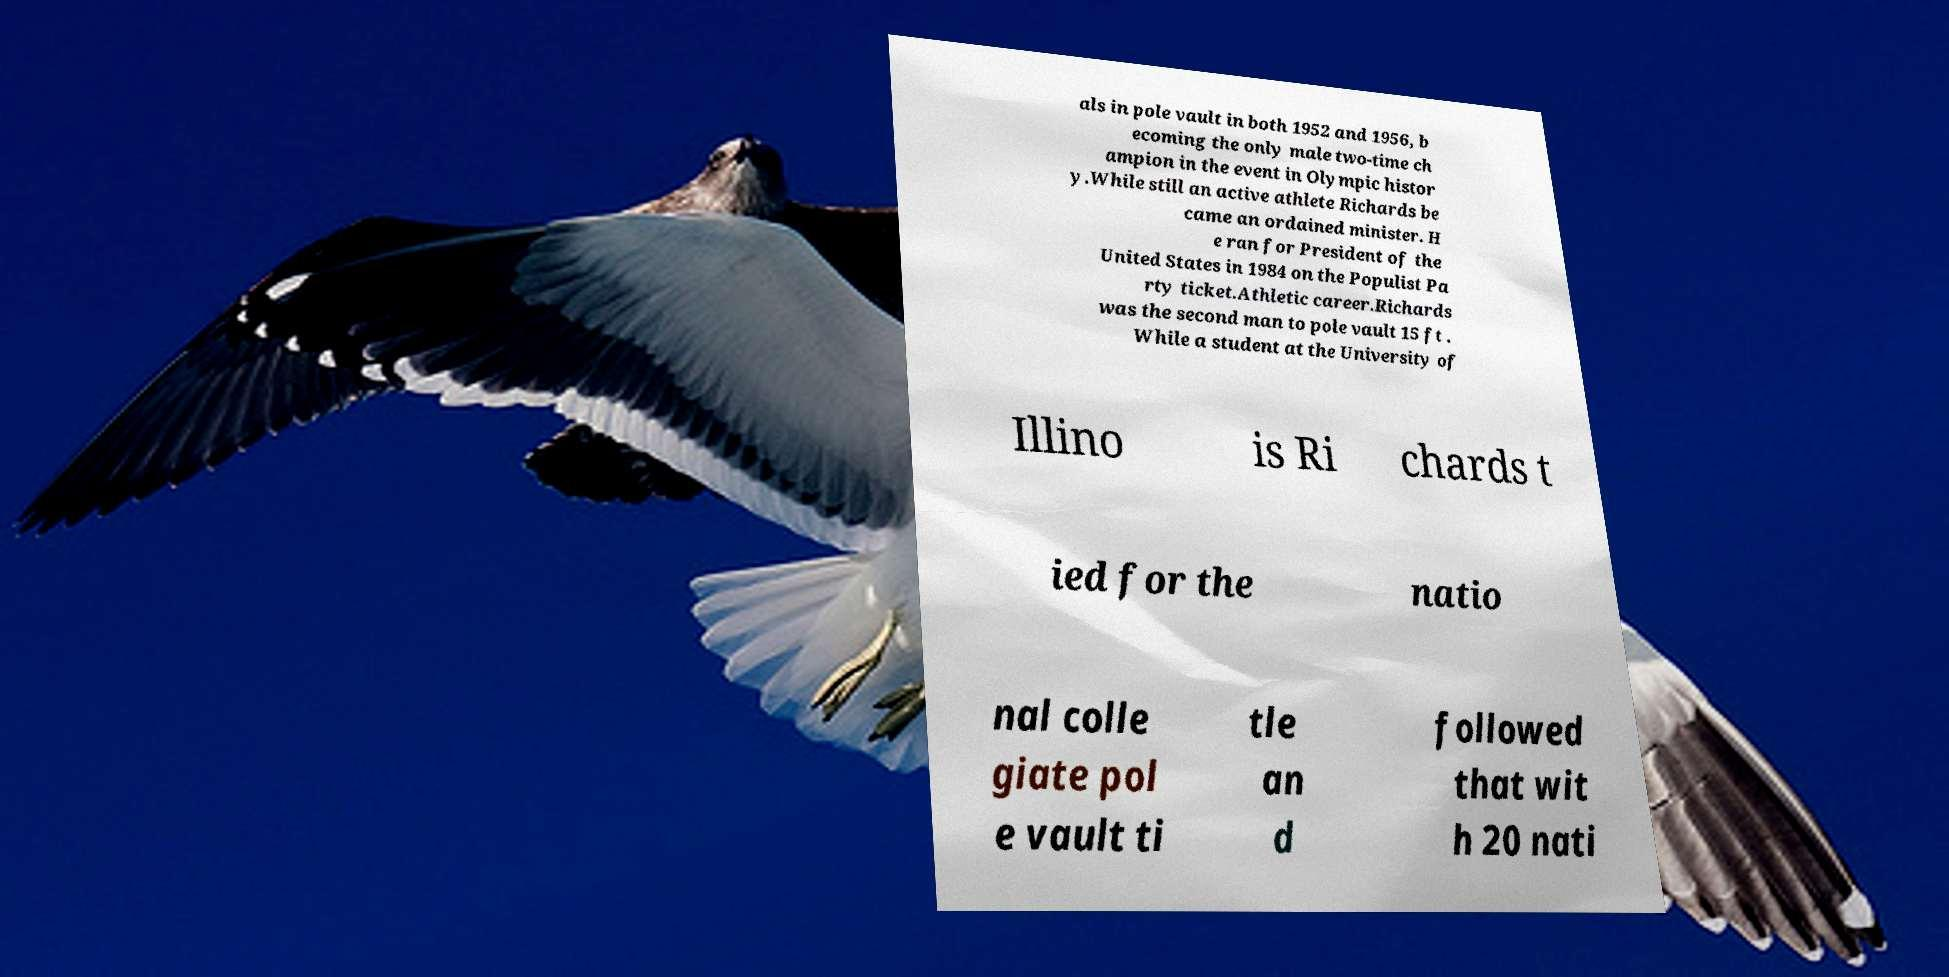There's text embedded in this image that I need extracted. Can you transcribe it verbatim? als in pole vault in both 1952 and 1956, b ecoming the only male two-time ch ampion in the event in Olympic histor y.While still an active athlete Richards be came an ordained minister. H e ran for President of the United States in 1984 on the Populist Pa rty ticket.Athletic career.Richards was the second man to pole vault 15 ft . While a student at the University of Illino is Ri chards t ied for the natio nal colle giate pol e vault ti tle an d followed that wit h 20 nati 